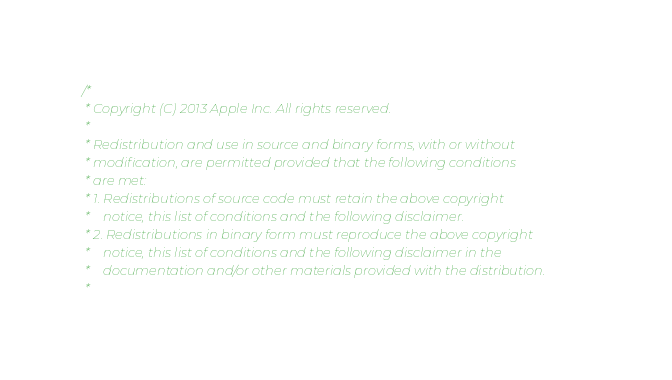<code> <loc_0><loc_0><loc_500><loc_500><_ObjectiveC_>/*
 * Copyright (C) 2013 Apple Inc. All rights reserved.
 *
 * Redistribution and use in source and binary forms, with or without
 * modification, are permitted provided that the following conditions
 * are met:
 * 1. Redistributions of source code must retain the above copyright
 *    notice, this list of conditions and the following disclaimer.
 * 2. Redistributions in binary form must reproduce the above copyright
 *    notice, this list of conditions and the following disclaimer in the
 *    documentation and/or other materials provided with the distribution.
 *</code> 